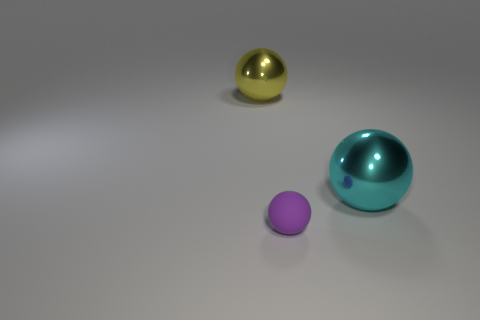Subtract all big yellow balls. How many balls are left? 2 Subtract all yellow spheres. How many spheres are left? 2 Subtract all red balls. Subtract all green cubes. How many balls are left? 3 Add 3 metallic cylinders. How many objects exist? 6 Subtract all cyan metallic spheres. Subtract all big cyan metal objects. How many objects are left? 1 Add 2 tiny purple objects. How many tiny purple objects are left? 3 Add 1 yellow balls. How many yellow balls exist? 2 Subtract 0 purple blocks. How many objects are left? 3 